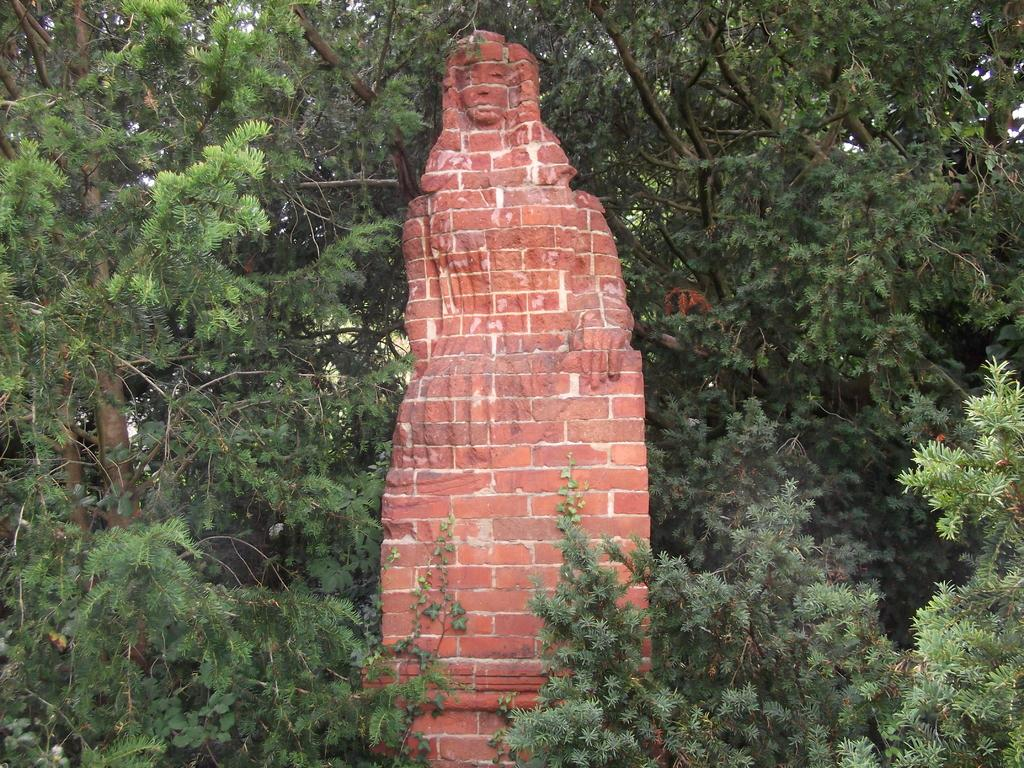What is the main subject of the image? There is a statue of a person in the image. What can be seen in the background of the image? There are trees in the background of the image. What type of alarm is ringing in the image? There is no alarm present in the image. How many apples are on the statue in the image? There are no apples present on the statue in the image. 